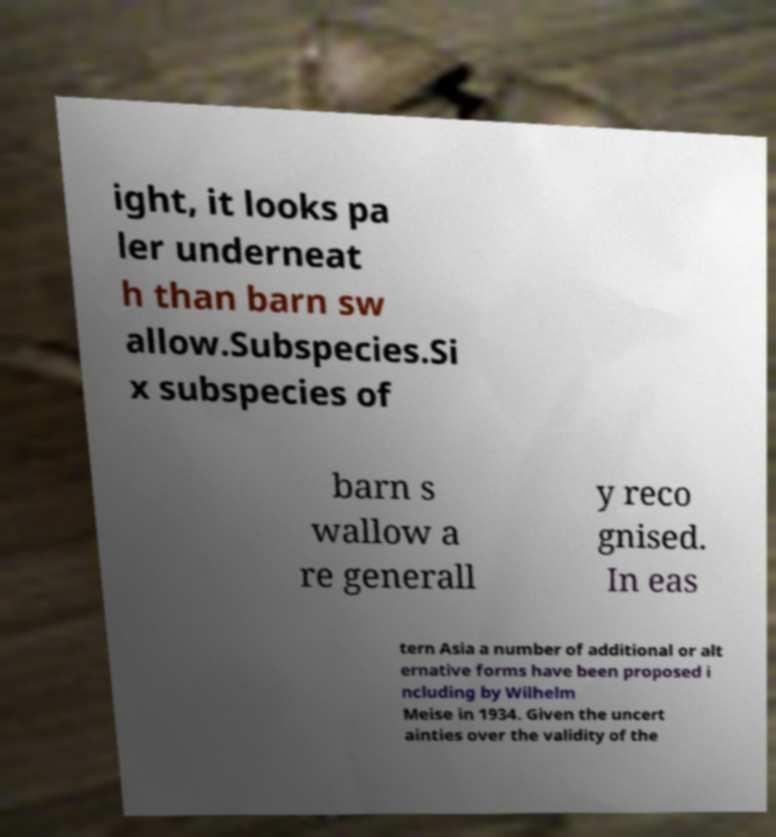Can you accurately transcribe the text from the provided image for me? ight, it looks pa ler underneat h than barn sw allow.Subspecies.Si x subspecies of barn s wallow a re generall y reco gnised. In eas tern Asia a number of additional or alt ernative forms have been proposed i ncluding by Wilhelm Meise in 1934. Given the uncert ainties over the validity of the 